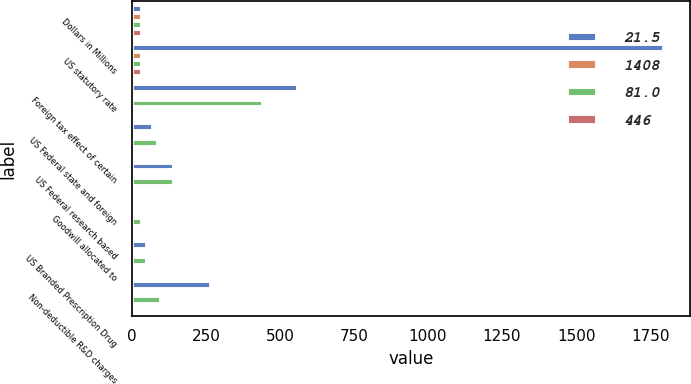Convert chart. <chart><loc_0><loc_0><loc_500><loc_500><stacked_bar_chart><ecel><fcel>Dollars in Millions<fcel>US statutory rate<fcel>Foreign tax effect of certain<fcel>US Federal state and foreign<fcel>US Federal research based<fcel>Goodwill allocated to<fcel>US Branded Prescription Drug<fcel>Non-deductible R&D charges<nl><fcel>21.5<fcel>34<fcel>1796<fcel>561<fcel>72<fcel>144<fcel>4<fcel>52<fcel>266<nl><fcel>1408<fcel>34<fcel>35<fcel>10.9<fcel>1.4<fcel>2.8<fcel>0.1<fcel>1<fcel>5.2<nl><fcel>81<fcel>34<fcel>34<fcel>442<fcel>87<fcel>144<fcel>34<fcel>52<fcel>100<nl><fcel>446<fcel>34<fcel>35<fcel>7.5<fcel>1.5<fcel>2.4<fcel>0.6<fcel>0.9<fcel>1.7<nl></chart> 